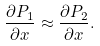Convert formula to latex. <formula><loc_0><loc_0><loc_500><loc_500>\frac { \partial P _ { 1 } } { \partial x } \approx \frac { \partial P _ { 2 } } { \partial x } .</formula> 